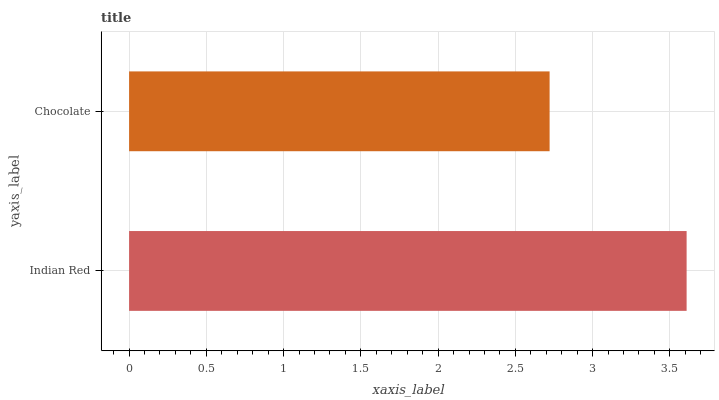Is Chocolate the minimum?
Answer yes or no. Yes. Is Indian Red the maximum?
Answer yes or no. Yes. Is Chocolate the maximum?
Answer yes or no. No. Is Indian Red greater than Chocolate?
Answer yes or no. Yes. Is Chocolate less than Indian Red?
Answer yes or no. Yes. Is Chocolate greater than Indian Red?
Answer yes or no. No. Is Indian Red less than Chocolate?
Answer yes or no. No. Is Indian Red the high median?
Answer yes or no. Yes. Is Chocolate the low median?
Answer yes or no. Yes. Is Chocolate the high median?
Answer yes or no. No. Is Indian Red the low median?
Answer yes or no. No. 